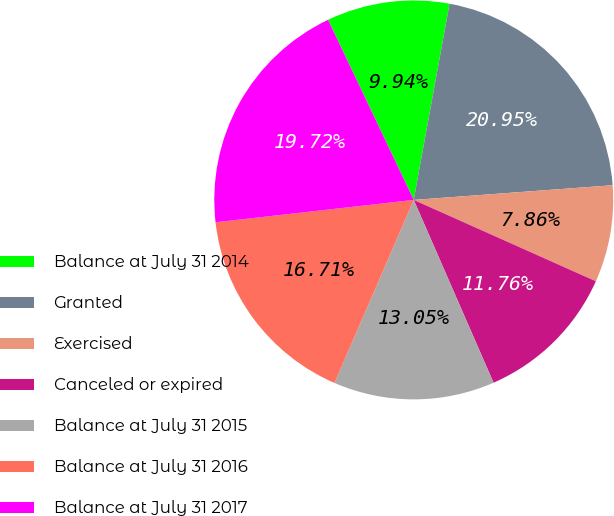Convert chart to OTSL. <chart><loc_0><loc_0><loc_500><loc_500><pie_chart><fcel>Balance at July 31 2014<fcel>Granted<fcel>Exercised<fcel>Canceled or expired<fcel>Balance at July 31 2015<fcel>Balance at July 31 2016<fcel>Balance at July 31 2017<nl><fcel>9.94%<fcel>20.95%<fcel>7.86%<fcel>11.76%<fcel>13.05%<fcel>16.71%<fcel>19.72%<nl></chart> 